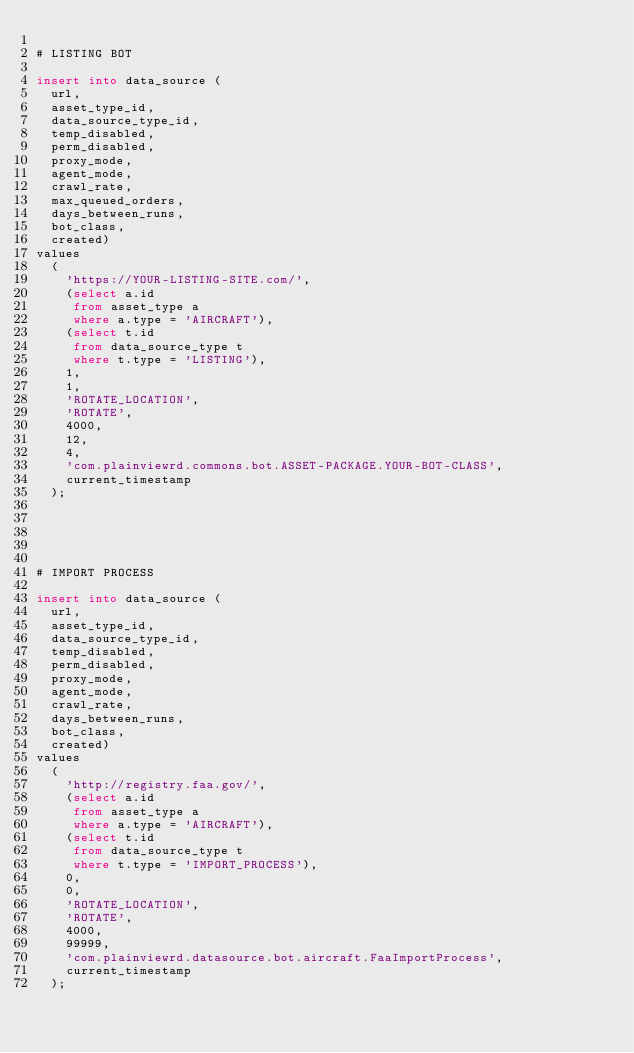Convert code to text. <code><loc_0><loc_0><loc_500><loc_500><_SQL_>
# LISTING BOT

insert into data_source (
	url,
	asset_type_id,
	data_source_type_id,
	temp_disabled,
	perm_disabled,
	proxy_mode,
	agent_mode,
	crawl_rate,
	max_queued_orders,
	days_between_runs,
	bot_class,
	created)
values
	(
		'https://YOUR-LISTING-SITE.com/',
		(select a.id
		 from asset_type a
		 where a.type = 'AIRCRAFT'),
		(select t.id
		 from data_source_type t
		 where t.type = 'LISTING'),
		1,
		1,
		'ROTATE_LOCATION',
		'ROTATE',
		4000,
		12,
		4,
		'com.plainviewrd.commons.bot.ASSET-PACKAGE.YOUR-BOT-CLASS',
		current_timestamp
	);





# IMPORT PROCESS

insert into data_source (
	url,
	asset_type_id,
	data_source_type_id,
	temp_disabled,
	perm_disabled,
	proxy_mode,
	agent_mode,
	crawl_rate,
	days_between_runs,
	bot_class,
	created)
values
	(
		'http://registry.faa.gov/',
		(select a.id
		 from asset_type a
		 where a.type = 'AIRCRAFT'),
		(select t.id
		 from data_source_type t
		 where t.type = 'IMPORT_PROCESS'),
		0,
		0,
		'ROTATE_LOCATION',
		'ROTATE',
		4000,
		99999,
		'com.plainviewrd.datasource.bot.aircraft.FaaImportProcess',
		current_timestamp
	);

</code> 